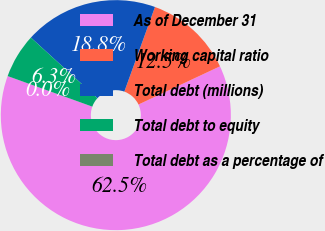<chart> <loc_0><loc_0><loc_500><loc_500><pie_chart><fcel>As of December 31<fcel>Working capital ratio<fcel>Total debt (millions)<fcel>Total debt to equity<fcel>Total debt as a percentage of<nl><fcel>62.48%<fcel>12.5%<fcel>18.75%<fcel>6.26%<fcel>0.01%<nl></chart> 